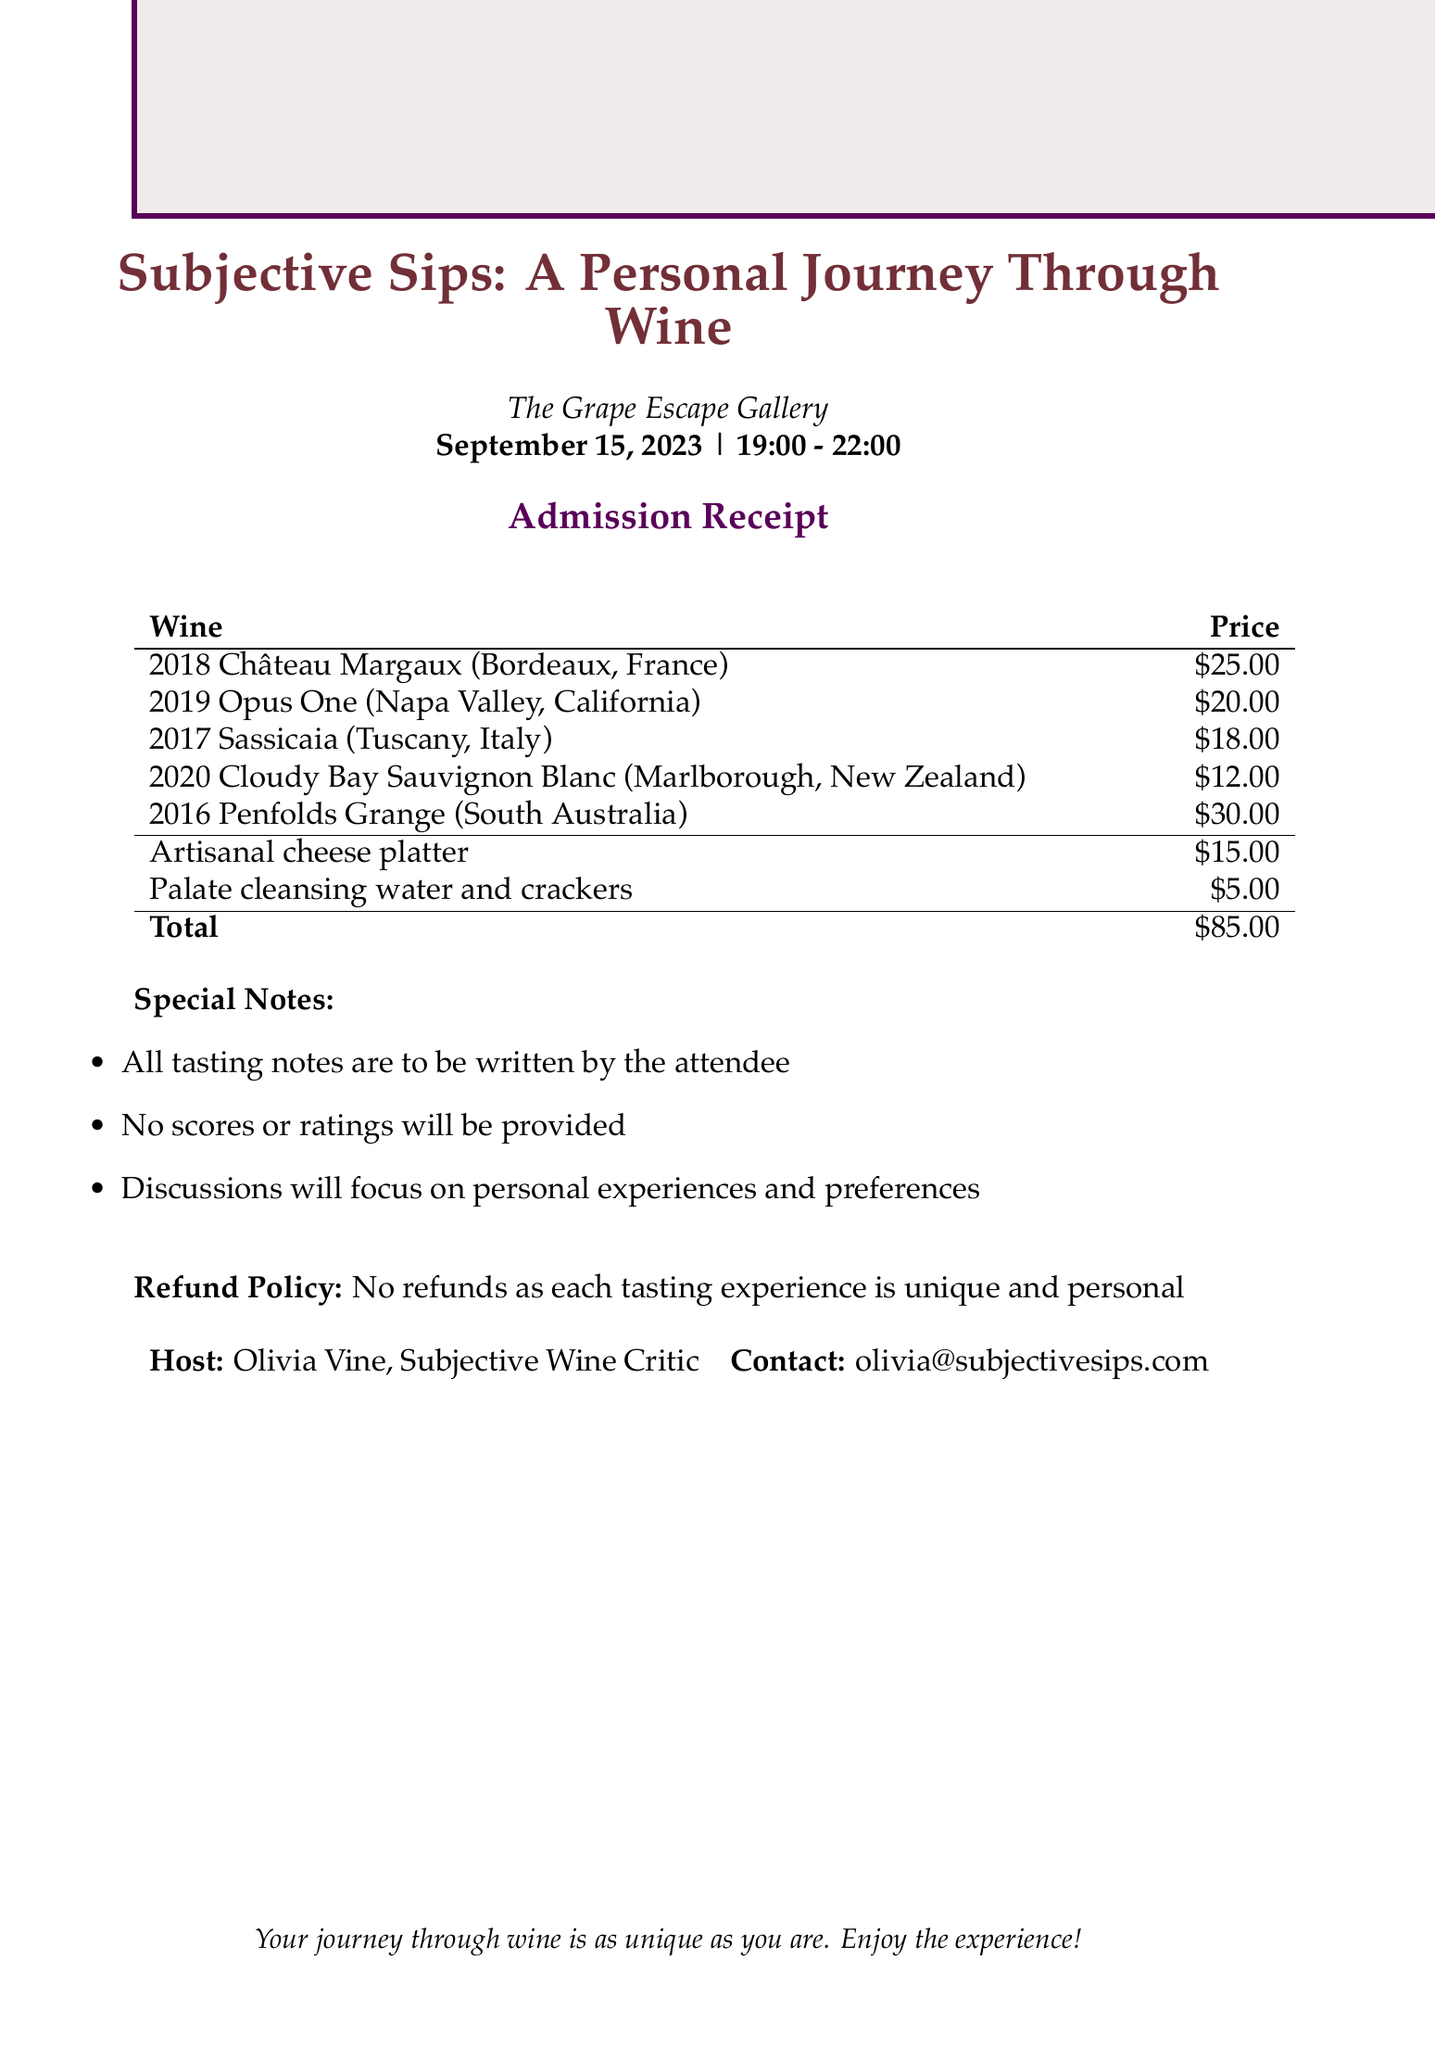What is the name of the event? The event name is specifically listed in the document as "Subjective Sips: A Personal Journey Through Wine."
Answer: Subjective Sips: A Personal Journey Through Wine What is the venue of the event? The venue is clearly mentioned in the document as "The Grape Escape Gallery."
Answer: The Grape Escape Gallery What is the total admission fee? The total admission fee is directly stated in the document as "$85.00."
Answer: $85.00 How much does the 2019 Opus One cost? The document provides the price of the 2019 Opus One as part of the itemized costs.
Answer: $20.00 What is the refund policy? The document specifies the refund policy stating "No refunds as each tasting experience is unique and personal."
Answer: No refunds as each tasting experience is unique and personal Which wine has the highest price? By comparing the itemized costs, the highest-priced wine is identified in the document.
Answer: $30.00 What additional item costs $5.00? The document includes an itemized list where one item is priced at $5.00.
Answer: Palate cleansing water and crackers What type of experiences will discussions focus on? The document mentions this to clarify the discussions that attendees can expect during the event.
Answer: Personal experiences and preferences Who is the host of the event? The document names the host specifically as "Olivia Vine, Subjective Wine Critic."
Answer: Olivia Vine, Subjective Wine Critic 